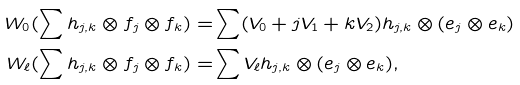Convert formula to latex. <formula><loc_0><loc_0><loc_500><loc_500>W _ { 0 } ( \sum h _ { j , k } \otimes f _ { j } \otimes f _ { k } ) = & \sum ( V _ { 0 } + j V _ { 1 } + k V _ { 2 } ) h _ { j , k } \otimes ( e _ { j } \otimes e _ { k } ) \\ W _ { \ell } ( \sum h _ { j , k } \otimes f _ { j } \otimes f _ { k } ) = & \sum V _ { \ell } h _ { j , k } \otimes ( e _ { j } \otimes e _ { k } ) ,</formula> 